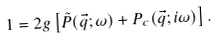<formula> <loc_0><loc_0><loc_500><loc_500>1 = 2 g \left [ \tilde { P } ( \vec { q } ; \omega ) + P _ { c } ( \vec { q } ; i \omega ) \right ] .</formula> 